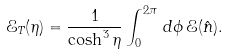Convert formula to latex. <formula><loc_0><loc_0><loc_500><loc_500>\mathcal { E } _ { T } ( \eta ) = \frac { 1 } { \cosh ^ { 3 } \eta } \int _ { 0 } ^ { 2 \pi } \, d \phi \, \mathcal { E } ( \hat { n } ) .</formula> 